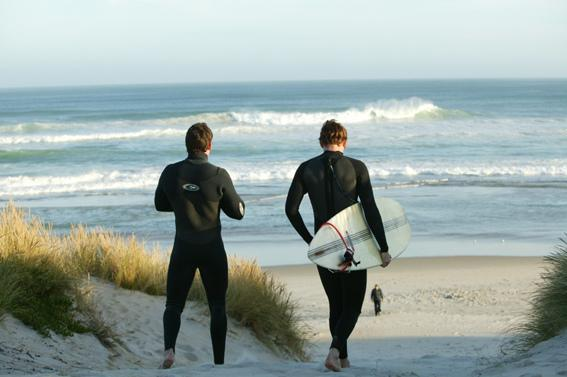Why do they have black suits on? surfing 